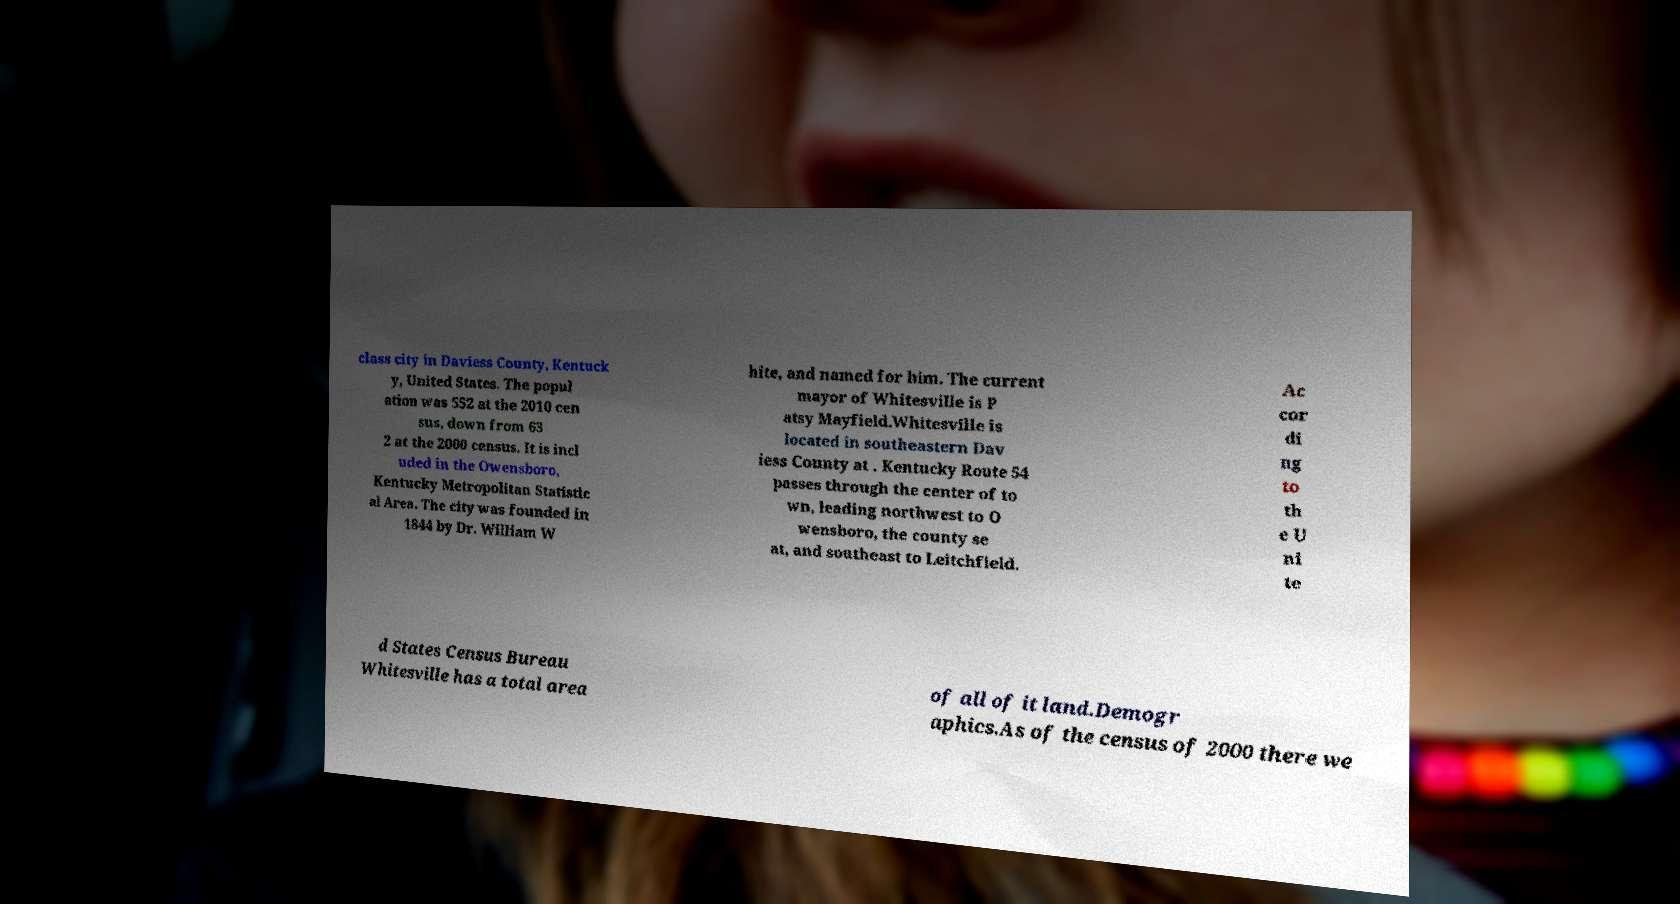Please identify and transcribe the text found in this image. class city in Daviess County, Kentuck y, United States. The popul ation was 552 at the 2010 cen sus, down from 63 2 at the 2000 census. It is incl uded in the Owensboro, Kentucky Metropolitan Statistic al Area. The city was founded in 1844 by Dr. William W hite, and named for him. The current mayor of Whitesville is P atsy Mayfield.Whitesville is located in southeastern Dav iess County at . Kentucky Route 54 passes through the center of to wn, leading northwest to O wensboro, the county se at, and southeast to Leitchfield. Ac cor di ng to th e U ni te d States Census Bureau Whitesville has a total area of all of it land.Demogr aphics.As of the census of 2000 there we 